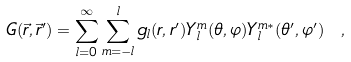Convert formula to latex. <formula><loc_0><loc_0><loc_500><loc_500>G ( \vec { r } , \vec { r } ^ { \prime } ) = \sum _ { l = 0 } ^ { \infty } \sum _ { m = - l } ^ { l } g _ { l } ( r , r ^ { \prime } ) Y _ { l } ^ { m } ( \theta , \varphi ) Y _ { l } ^ { m \ast } ( \theta ^ { \prime } , \varphi ^ { \prime } ) \ ,</formula> 